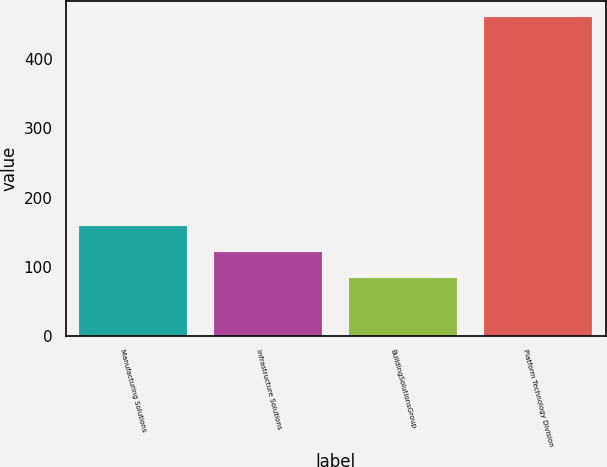Convert chart. <chart><loc_0><loc_0><loc_500><loc_500><bar_chart><fcel>Manufacturing Solutions<fcel>Infrastructure Solutions<fcel>BuildingSolutionsGroup<fcel>Platform Technology Division<nl><fcel>158.7<fcel>120.8<fcel>82.9<fcel>461.9<nl></chart> 